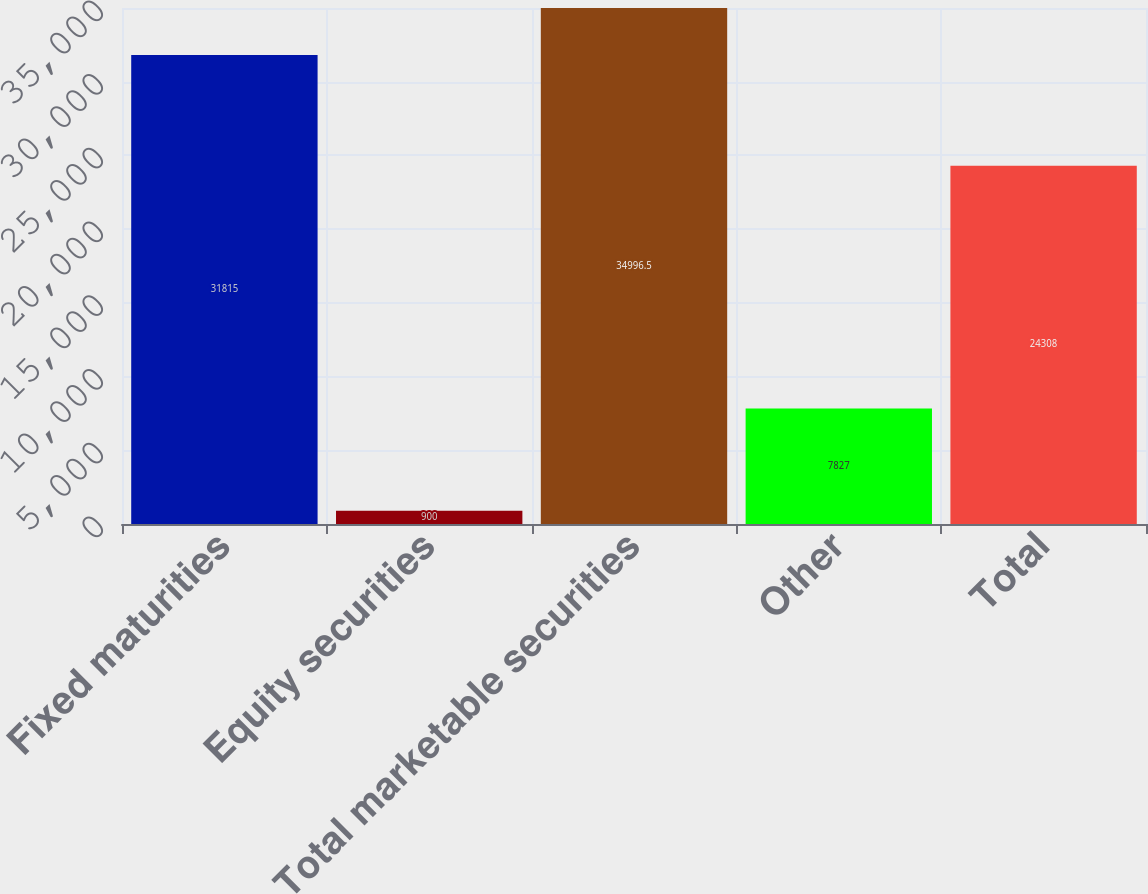<chart> <loc_0><loc_0><loc_500><loc_500><bar_chart><fcel>Fixed maturities<fcel>Equity securities<fcel>Total marketable securities<fcel>Other<fcel>Total<nl><fcel>31815<fcel>900<fcel>34996.5<fcel>7827<fcel>24308<nl></chart> 